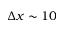Convert formula to latex. <formula><loc_0><loc_0><loc_500><loc_500>\Delta x \sim 1 0</formula> 